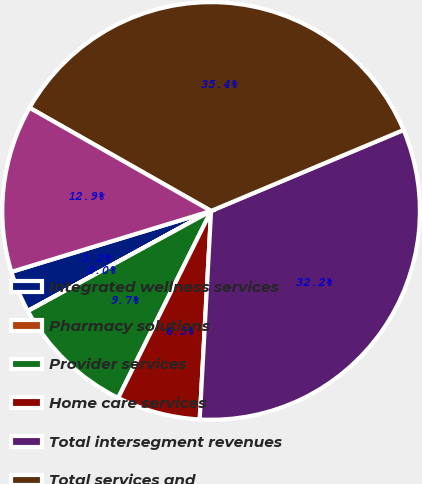Convert chart to OTSL. <chart><loc_0><loc_0><loc_500><loc_500><pie_chart><fcel>Integrated wellness services<fcel>Pharmacy solutions<fcel>Provider services<fcel>Home care services<fcel>Total intersegment revenues<fcel>Total services and<fcel>Income before income taxes<nl><fcel>3.24%<fcel>0.01%<fcel>9.7%<fcel>6.47%<fcel>32.21%<fcel>35.44%<fcel>12.94%<nl></chart> 